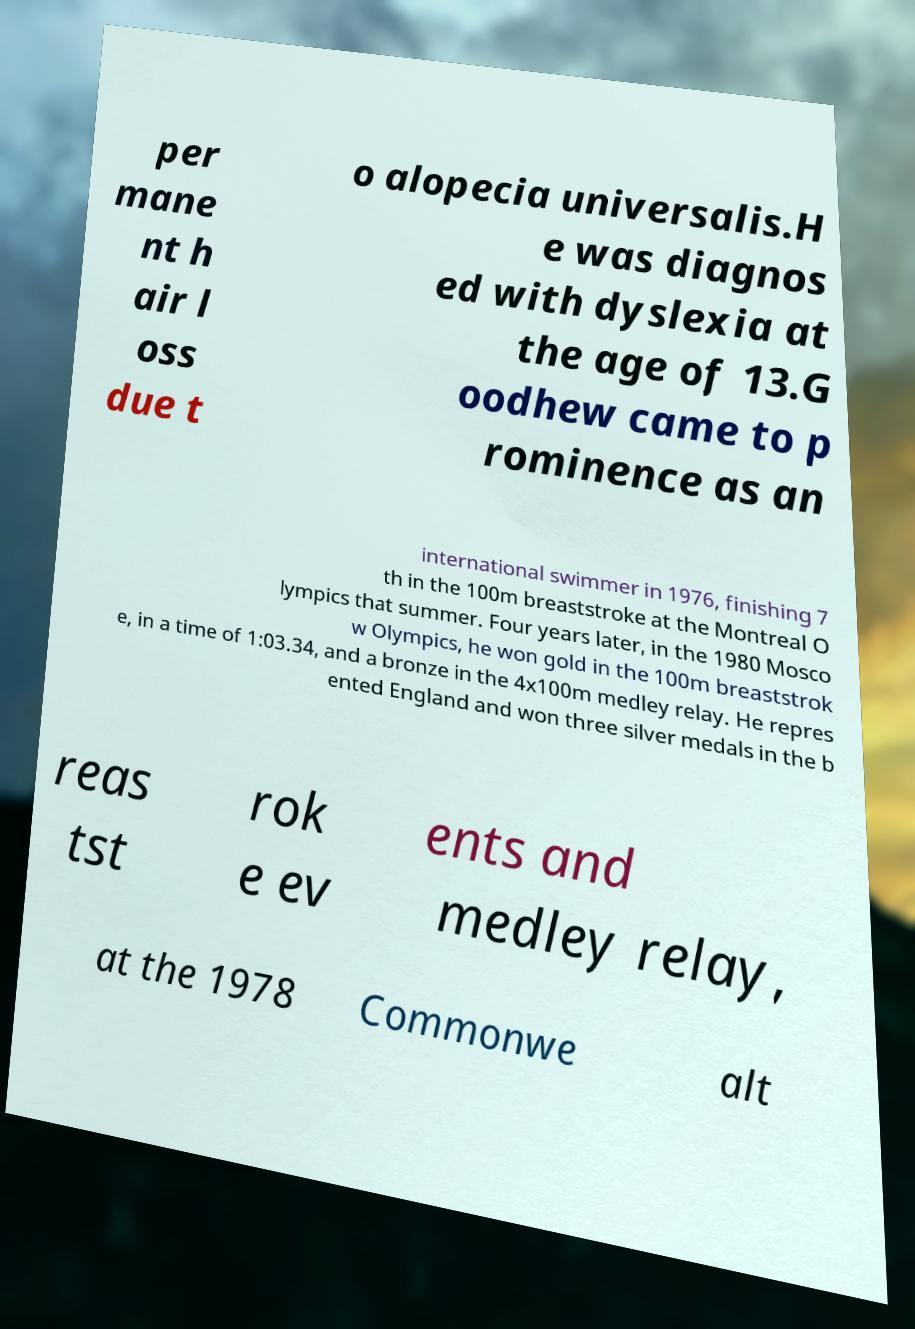What messages or text are displayed in this image? I need them in a readable, typed format. per mane nt h air l oss due t o alopecia universalis.H e was diagnos ed with dyslexia at the age of 13.G oodhew came to p rominence as an international swimmer in 1976, finishing 7 th in the 100m breaststroke at the Montreal O lympics that summer. Four years later, in the 1980 Mosco w Olympics, he won gold in the 100m breaststrok e, in a time of 1:03.34, and a bronze in the 4x100m medley relay. He repres ented England and won three silver medals in the b reas tst rok e ev ents and medley relay, at the 1978 Commonwe alt 